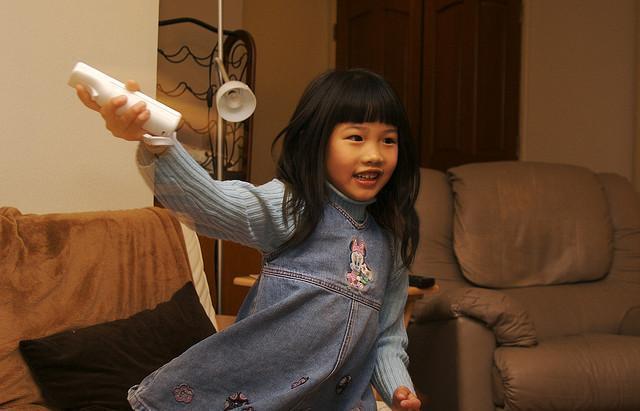How many kids?
Give a very brief answer. 1. How many people are in the photo?
Give a very brief answer. 1. How many bananas are there?
Give a very brief answer. 0. 